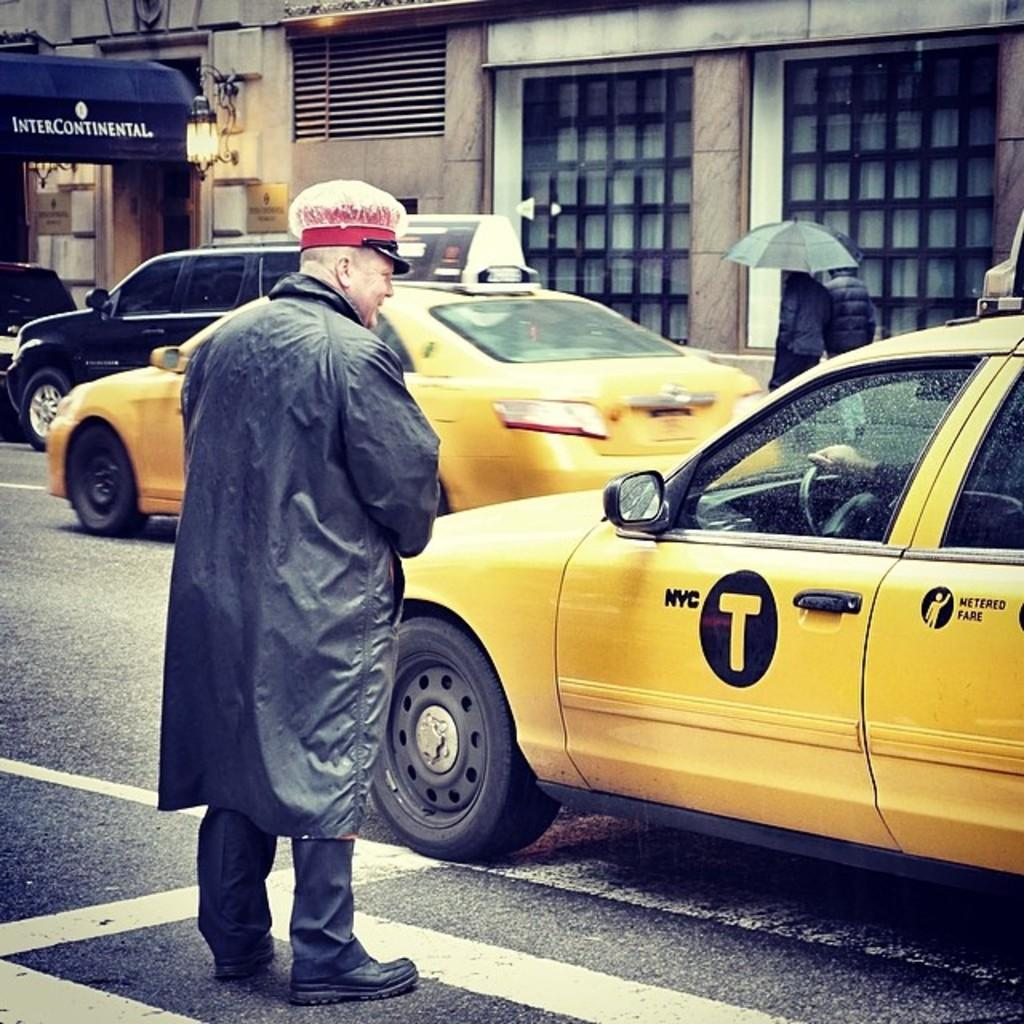<image>
Offer a succinct explanation of the picture presented. a taxi with the letter T on it 